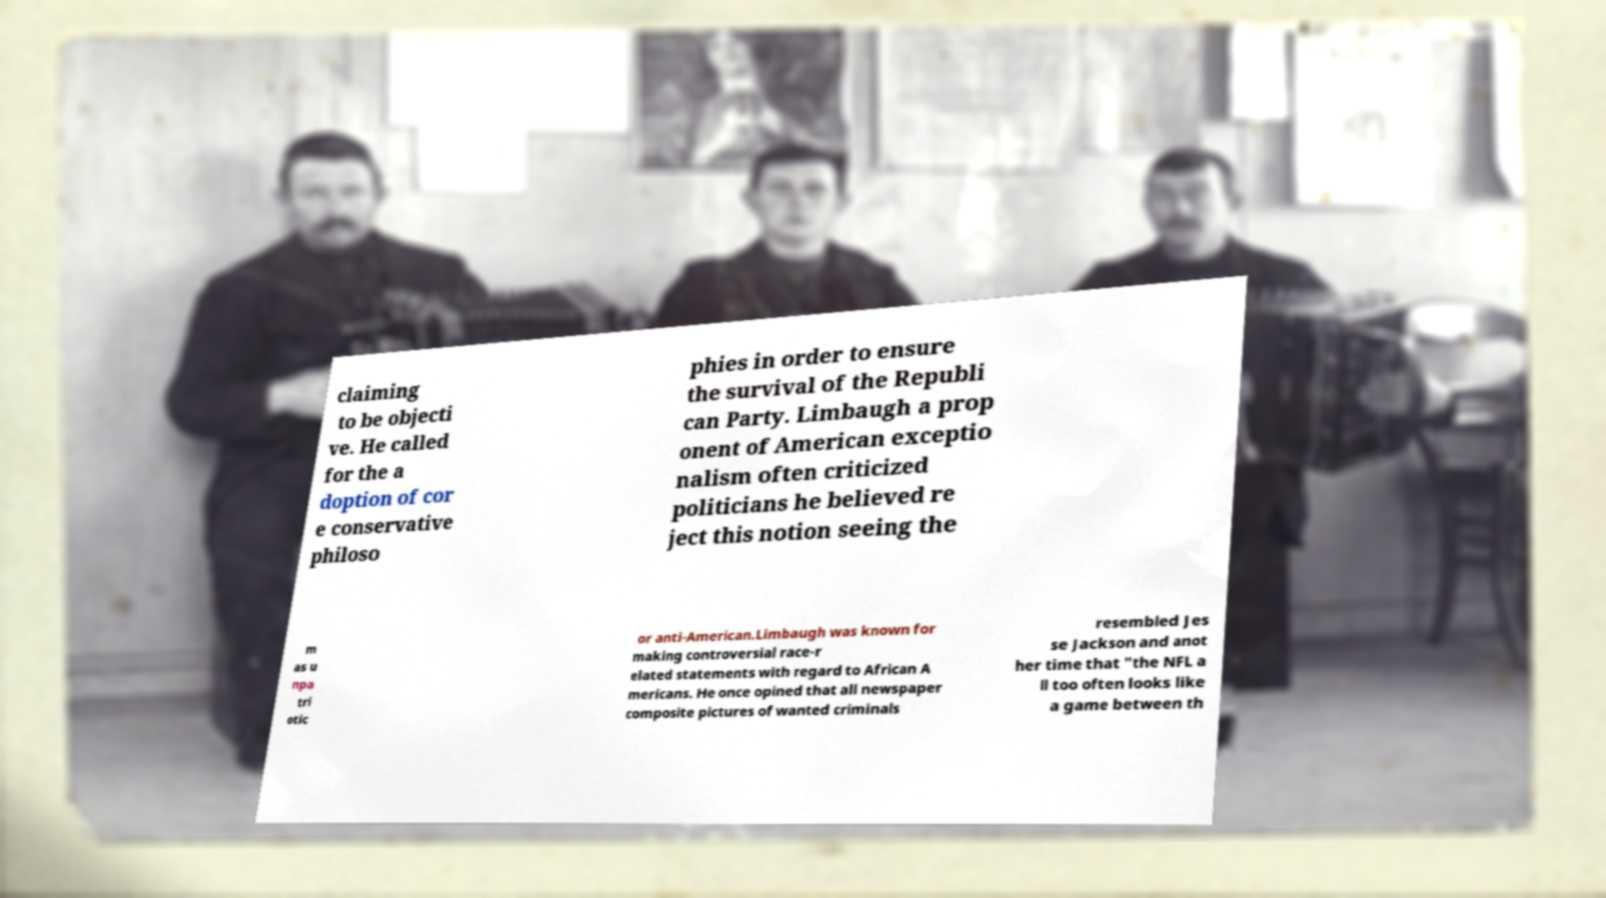Can you read and provide the text displayed in the image?This photo seems to have some interesting text. Can you extract and type it out for me? claiming to be objecti ve. He called for the a doption of cor e conservative philoso phies in order to ensure the survival of the Republi can Party. Limbaugh a prop onent of American exceptio nalism often criticized politicians he believed re ject this notion seeing the m as u npa tri otic or anti-American.Limbaugh was known for making controversial race-r elated statements with regard to African A mericans. He once opined that all newspaper composite pictures of wanted criminals resembled Jes se Jackson and anot her time that "the NFL a ll too often looks like a game between th 